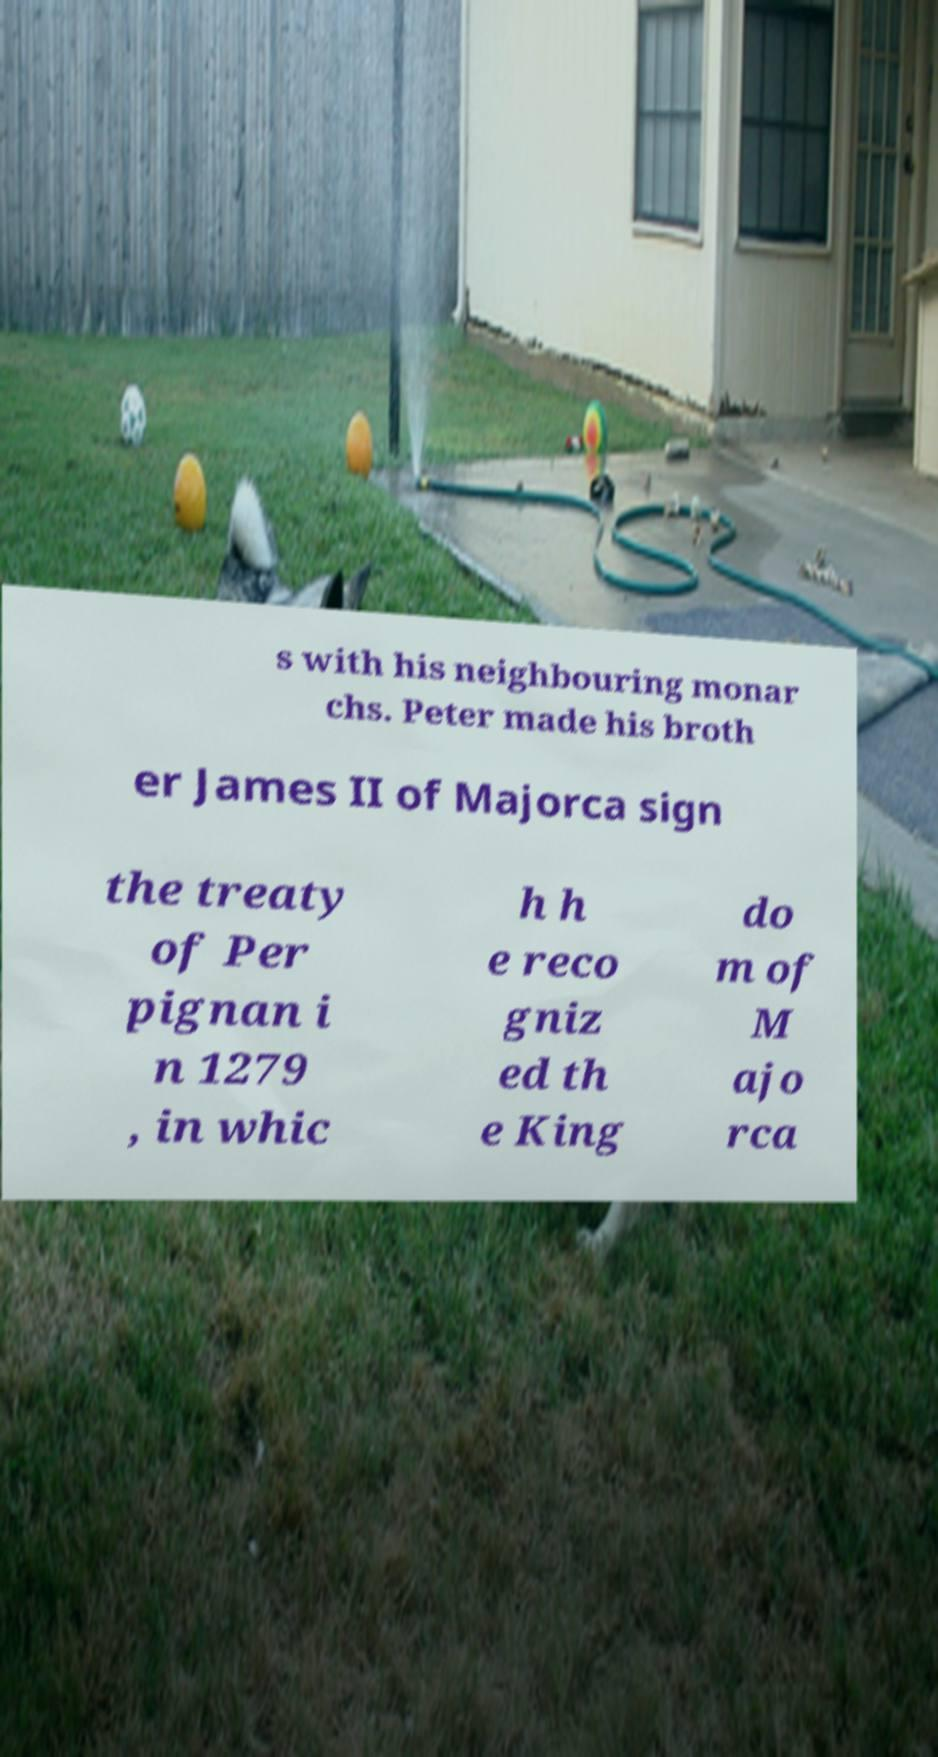I need the written content from this picture converted into text. Can you do that? s with his neighbouring monar chs. Peter made his broth er James II of Majorca sign the treaty of Per pignan i n 1279 , in whic h h e reco gniz ed th e King do m of M ajo rca 